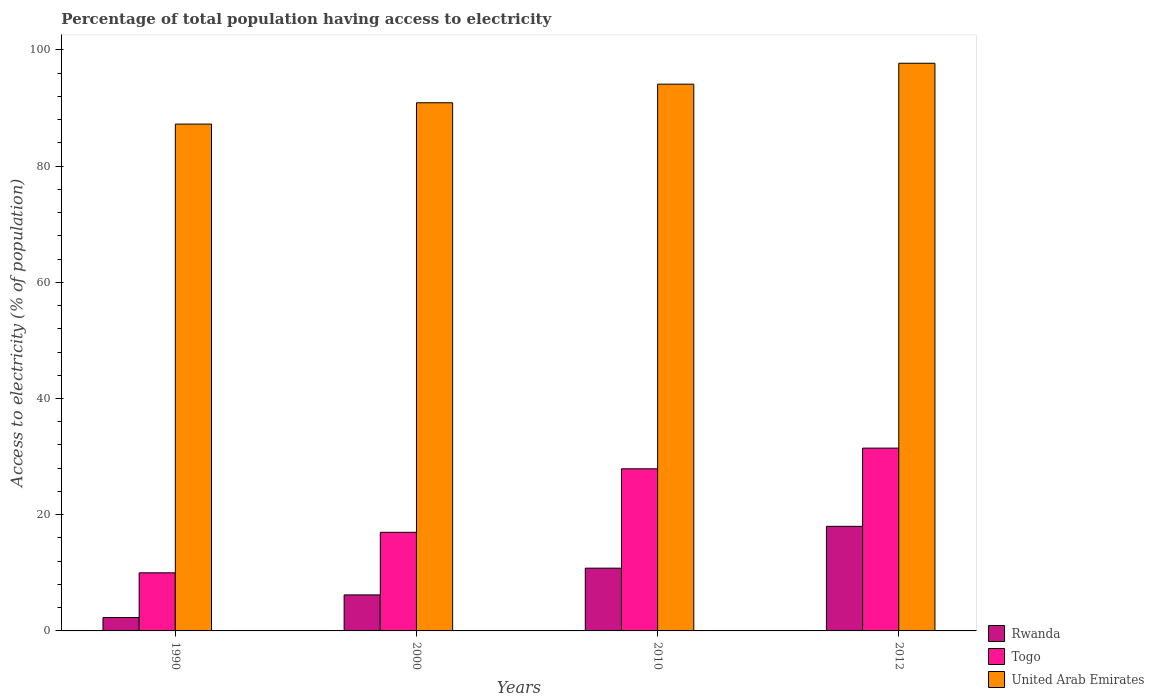Are the number of bars on each tick of the X-axis equal?
Give a very brief answer. Yes. How many bars are there on the 3rd tick from the right?
Provide a short and direct response. 3. What is the label of the 1st group of bars from the left?
Make the answer very short. 1990. In how many cases, is the number of bars for a given year not equal to the number of legend labels?
Provide a short and direct response. 0. What is the percentage of population that have access to electricity in United Arab Emirates in 2010?
Give a very brief answer. 94.1. Across all years, what is the minimum percentage of population that have access to electricity in Rwanda?
Your answer should be very brief. 2.3. In which year was the percentage of population that have access to electricity in Togo minimum?
Offer a terse response. 1990. What is the total percentage of population that have access to electricity in Rwanda in the graph?
Your answer should be compact. 37.3. What is the difference between the percentage of population that have access to electricity in Togo in 2000 and that in 2012?
Keep it short and to the point. -14.49. What is the difference between the percentage of population that have access to electricity in Togo in 2010 and the percentage of population that have access to electricity in Rwanda in 1990?
Your answer should be compact. 25.6. What is the average percentage of population that have access to electricity in Togo per year?
Offer a very short reply. 21.58. In the year 2010, what is the difference between the percentage of population that have access to electricity in Togo and percentage of population that have access to electricity in Rwanda?
Your response must be concise. 17.1. In how many years, is the percentage of population that have access to electricity in Rwanda greater than 24 %?
Give a very brief answer. 0. What is the ratio of the percentage of population that have access to electricity in Togo in 2000 to that in 2010?
Offer a very short reply. 0.61. Is the percentage of population that have access to electricity in United Arab Emirates in 2000 less than that in 2010?
Your answer should be compact. Yes. Is the difference between the percentage of population that have access to electricity in Togo in 1990 and 2012 greater than the difference between the percentage of population that have access to electricity in Rwanda in 1990 and 2012?
Make the answer very short. No. What is the difference between the highest and the second highest percentage of population that have access to electricity in Togo?
Your response must be concise. 3.56. What is the difference between the highest and the lowest percentage of population that have access to electricity in Togo?
Offer a terse response. 21.46. What does the 1st bar from the left in 2012 represents?
Offer a very short reply. Rwanda. What does the 1st bar from the right in 2000 represents?
Make the answer very short. United Arab Emirates. How many years are there in the graph?
Make the answer very short. 4. What is the difference between two consecutive major ticks on the Y-axis?
Your answer should be very brief. 20. Does the graph contain grids?
Your response must be concise. No. Where does the legend appear in the graph?
Make the answer very short. Bottom right. What is the title of the graph?
Provide a short and direct response. Percentage of total population having access to electricity. Does "Togo" appear as one of the legend labels in the graph?
Make the answer very short. Yes. What is the label or title of the Y-axis?
Make the answer very short. Access to electricity (% of population). What is the Access to electricity (% of population) in Rwanda in 1990?
Provide a succinct answer. 2.3. What is the Access to electricity (% of population) of United Arab Emirates in 1990?
Give a very brief answer. 87.23. What is the Access to electricity (% of population) in Togo in 2000?
Offer a terse response. 16.97. What is the Access to electricity (% of population) in United Arab Emirates in 2000?
Ensure brevity in your answer.  90.9. What is the Access to electricity (% of population) of Rwanda in 2010?
Your answer should be very brief. 10.8. What is the Access to electricity (% of population) in Togo in 2010?
Your answer should be very brief. 27.9. What is the Access to electricity (% of population) in United Arab Emirates in 2010?
Give a very brief answer. 94.1. What is the Access to electricity (% of population) in Togo in 2012?
Offer a very short reply. 31.46. What is the Access to electricity (% of population) in United Arab Emirates in 2012?
Make the answer very short. 97.7. Across all years, what is the maximum Access to electricity (% of population) of Togo?
Make the answer very short. 31.46. Across all years, what is the maximum Access to electricity (% of population) in United Arab Emirates?
Your response must be concise. 97.7. Across all years, what is the minimum Access to electricity (% of population) in Togo?
Ensure brevity in your answer.  10. Across all years, what is the minimum Access to electricity (% of population) of United Arab Emirates?
Make the answer very short. 87.23. What is the total Access to electricity (% of population) of Rwanda in the graph?
Provide a succinct answer. 37.3. What is the total Access to electricity (% of population) in Togo in the graph?
Give a very brief answer. 86.33. What is the total Access to electricity (% of population) in United Arab Emirates in the graph?
Offer a very short reply. 369.92. What is the difference between the Access to electricity (% of population) in Togo in 1990 and that in 2000?
Your response must be concise. -6.97. What is the difference between the Access to electricity (% of population) in United Arab Emirates in 1990 and that in 2000?
Your answer should be compact. -3.67. What is the difference between the Access to electricity (% of population) in Togo in 1990 and that in 2010?
Your answer should be very brief. -17.9. What is the difference between the Access to electricity (% of population) in United Arab Emirates in 1990 and that in 2010?
Make the answer very short. -6.87. What is the difference between the Access to electricity (% of population) in Rwanda in 1990 and that in 2012?
Keep it short and to the point. -15.7. What is the difference between the Access to electricity (% of population) in Togo in 1990 and that in 2012?
Your answer should be compact. -21.46. What is the difference between the Access to electricity (% of population) in United Arab Emirates in 1990 and that in 2012?
Keep it short and to the point. -10.47. What is the difference between the Access to electricity (% of population) of Togo in 2000 and that in 2010?
Offer a very short reply. -10.93. What is the difference between the Access to electricity (% of population) of United Arab Emirates in 2000 and that in 2010?
Offer a terse response. -3.2. What is the difference between the Access to electricity (% of population) of Rwanda in 2000 and that in 2012?
Provide a succinct answer. -11.8. What is the difference between the Access to electricity (% of population) in Togo in 2000 and that in 2012?
Offer a terse response. -14.49. What is the difference between the Access to electricity (% of population) of United Arab Emirates in 2000 and that in 2012?
Make the answer very short. -6.8. What is the difference between the Access to electricity (% of population) in Togo in 2010 and that in 2012?
Provide a succinct answer. -3.56. What is the difference between the Access to electricity (% of population) in United Arab Emirates in 2010 and that in 2012?
Your answer should be compact. -3.6. What is the difference between the Access to electricity (% of population) of Rwanda in 1990 and the Access to electricity (% of population) of Togo in 2000?
Your answer should be very brief. -14.67. What is the difference between the Access to electricity (% of population) in Rwanda in 1990 and the Access to electricity (% of population) in United Arab Emirates in 2000?
Ensure brevity in your answer.  -88.6. What is the difference between the Access to electricity (% of population) in Togo in 1990 and the Access to electricity (% of population) in United Arab Emirates in 2000?
Provide a succinct answer. -80.9. What is the difference between the Access to electricity (% of population) in Rwanda in 1990 and the Access to electricity (% of population) in Togo in 2010?
Your answer should be compact. -25.6. What is the difference between the Access to electricity (% of population) of Rwanda in 1990 and the Access to electricity (% of population) of United Arab Emirates in 2010?
Your answer should be compact. -91.8. What is the difference between the Access to electricity (% of population) in Togo in 1990 and the Access to electricity (% of population) in United Arab Emirates in 2010?
Provide a short and direct response. -84.1. What is the difference between the Access to electricity (% of population) of Rwanda in 1990 and the Access to electricity (% of population) of Togo in 2012?
Make the answer very short. -29.16. What is the difference between the Access to electricity (% of population) in Rwanda in 1990 and the Access to electricity (% of population) in United Arab Emirates in 2012?
Your answer should be very brief. -95.4. What is the difference between the Access to electricity (% of population) in Togo in 1990 and the Access to electricity (% of population) in United Arab Emirates in 2012?
Provide a short and direct response. -87.7. What is the difference between the Access to electricity (% of population) of Rwanda in 2000 and the Access to electricity (% of population) of Togo in 2010?
Your response must be concise. -21.7. What is the difference between the Access to electricity (% of population) in Rwanda in 2000 and the Access to electricity (% of population) in United Arab Emirates in 2010?
Offer a terse response. -87.9. What is the difference between the Access to electricity (% of population) in Togo in 2000 and the Access to electricity (% of population) in United Arab Emirates in 2010?
Offer a terse response. -77.13. What is the difference between the Access to electricity (% of population) of Rwanda in 2000 and the Access to electricity (% of population) of Togo in 2012?
Make the answer very short. -25.26. What is the difference between the Access to electricity (% of population) in Rwanda in 2000 and the Access to electricity (% of population) in United Arab Emirates in 2012?
Ensure brevity in your answer.  -91.5. What is the difference between the Access to electricity (% of population) in Togo in 2000 and the Access to electricity (% of population) in United Arab Emirates in 2012?
Your answer should be very brief. -80.73. What is the difference between the Access to electricity (% of population) of Rwanda in 2010 and the Access to electricity (% of population) of Togo in 2012?
Offer a terse response. -20.66. What is the difference between the Access to electricity (% of population) in Rwanda in 2010 and the Access to electricity (% of population) in United Arab Emirates in 2012?
Provide a succinct answer. -86.9. What is the difference between the Access to electricity (% of population) in Togo in 2010 and the Access to electricity (% of population) in United Arab Emirates in 2012?
Offer a very short reply. -69.8. What is the average Access to electricity (% of population) in Rwanda per year?
Offer a terse response. 9.32. What is the average Access to electricity (% of population) in Togo per year?
Your answer should be compact. 21.58. What is the average Access to electricity (% of population) in United Arab Emirates per year?
Give a very brief answer. 92.48. In the year 1990, what is the difference between the Access to electricity (% of population) in Rwanda and Access to electricity (% of population) in Togo?
Keep it short and to the point. -7.7. In the year 1990, what is the difference between the Access to electricity (% of population) of Rwanda and Access to electricity (% of population) of United Arab Emirates?
Your answer should be compact. -84.93. In the year 1990, what is the difference between the Access to electricity (% of population) in Togo and Access to electricity (% of population) in United Arab Emirates?
Make the answer very short. -77.23. In the year 2000, what is the difference between the Access to electricity (% of population) in Rwanda and Access to electricity (% of population) in Togo?
Offer a very short reply. -10.77. In the year 2000, what is the difference between the Access to electricity (% of population) in Rwanda and Access to electricity (% of population) in United Arab Emirates?
Make the answer very short. -84.7. In the year 2000, what is the difference between the Access to electricity (% of population) of Togo and Access to electricity (% of population) of United Arab Emirates?
Ensure brevity in your answer.  -73.93. In the year 2010, what is the difference between the Access to electricity (% of population) of Rwanda and Access to electricity (% of population) of Togo?
Your answer should be very brief. -17.1. In the year 2010, what is the difference between the Access to electricity (% of population) in Rwanda and Access to electricity (% of population) in United Arab Emirates?
Provide a short and direct response. -83.3. In the year 2010, what is the difference between the Access to electricity (% of population) in Togo and Access to electricity (% of population) in United Arab Emirates?
Your response must be concise. -66.2. In the year 2012, what is the difference between the Access to electricity (% of population) of Rwanda and Access to electricity (% of population) of Togo?
Offer a terse response. -13.46. In the year 2012, what is the difference between the Access to electricity (% of population) in Rwanda and Access to electricity (% of population) in United Arab Emirates?
Provide a succinct answer. -79.7. In the year 2012, what is the difference between the Access to electricity (% of population) in Togo and Access to electricity (% of population) in United Arab Emirates?
Make the answer very short. -66.24. What is the ratio of the Access to electricity (% of population) in Rwanda in 1990 to that in 2000?
Provide a succinct answer. 0.37. What is the ratio of the Access to electricity (% of population) of Togo in 1990 to that in 2000?
Ensure brevity in your answer.  0.59. What is the ratio of the Access to electricity (% of population) in United Arab Emirates in 1990 to that in 2000?
Your response must be concise. 0.96. What is the ratio of the Access to electricity (% of population) in Rwanda in 1990 to that in 2010?
Your answer should be very brief. 0.21. What is the ratio of the Access to electricity (% of population) of Togo in 1990 to that in 2010?
Keep it short and to the point. 0.36. What is the ratio of the Access to electricity (% of population) of United Arab Emirates in 1990 to that in 2010?
Make the answer very short. 0.93. What is the ratio of the Access to electricity (% of population) of Rwanda in 1990 to that in 2012?
Offer a very short reply. 0.13. What is the ratio of the Access to electricity (% of population) of Togo in 1990 to that in 2012?
Offer a terse response. 0.32. What is the ratio of the Access to electricity (% of population) of United Arab Emirates in 1990 to that in 2012?
Your answer should be compact. 0.89. What is the ratio of the Access to electricity (% of population) of Rwanda in 2000 to that in 2010?
Your response must be concise. 0.57. What is the ratio of the Access to electricity (% of population) of Togo in 2000 to that in 2010?
Your response must be concise. 0.61. What is the ratio of the Access to electricity (% of population) of Rwanda in 2000 to that in 2012?
Keep it short and to the point. 0.34. What is the ratio of the Access to electricity (% of population) of Togo in 2000 to that in 2012?
Provide a short and direct response. 0.54. What is the ratio of the Access to electricity (% of population) in United Arab Emirates in 2000 to that in 2012?
Your response must be concise. 0.93. What is the ratio of the Access to electricity (% of population) of Rwanda in 2010 to that in 2012?
Your answer should be very brief. 0.6. What is the ratio of the Access to electricity (% of population) of Togo in 2010 to that in 2012?
Your response must be concise. 0.89. What is the ratio of the Access to electricity (% of population) of United Arab Emirates in 2010 to that in 2012?
Offer a very short reply. 0.96. What is the difference between the highest and the second highest Access to electricity (% of population) in Rwanda?
Provide a succinct answer. 7.2. What is the difference between the highest and the second highest Access to electricity (% of population) of Togo?
Your answer should be compact. 3.56. What is the difference between the highest and the second highest Access to electricity (% of population) of United Arab Emirates?
Offer a very short reply. 3.6. What is the difference between the highest and the lowest Access to electricity (% of population) in Togo?
Make the answer very short. 21.46. What is the difference between the highest and the lowest Access to electricity (% of population) in United Arab Emirates?
Give a very brief answer. 10.47. 